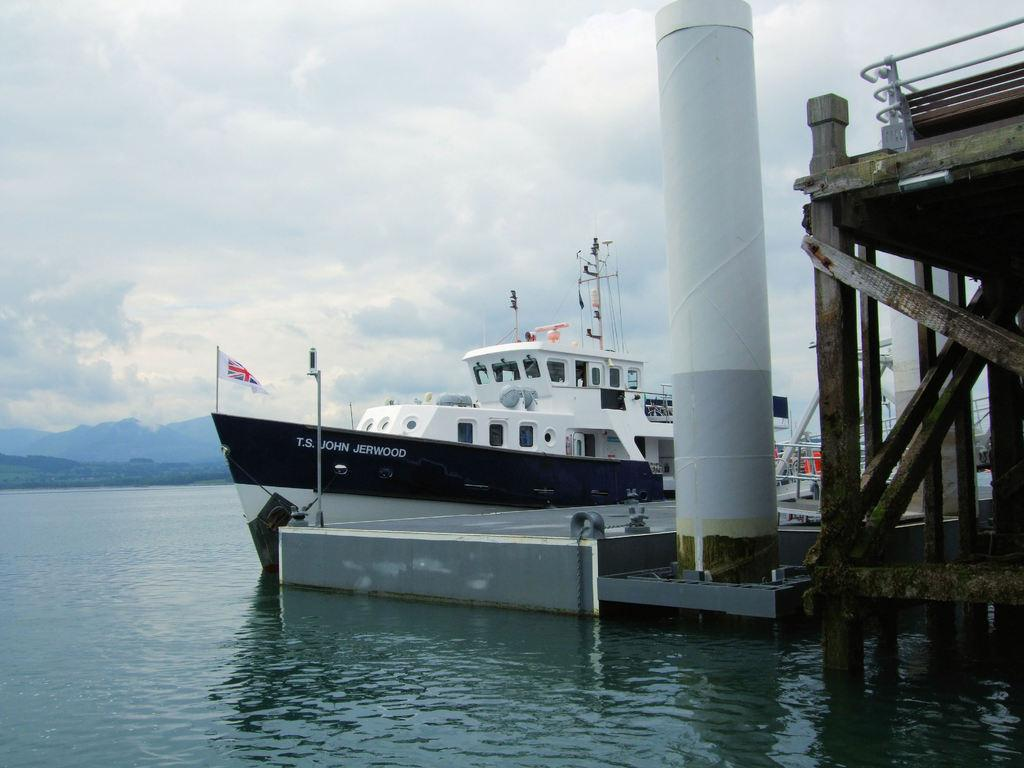<image>
Describe the image concisely. A black and white boat named after John Jerwood is tied to the harbor. 